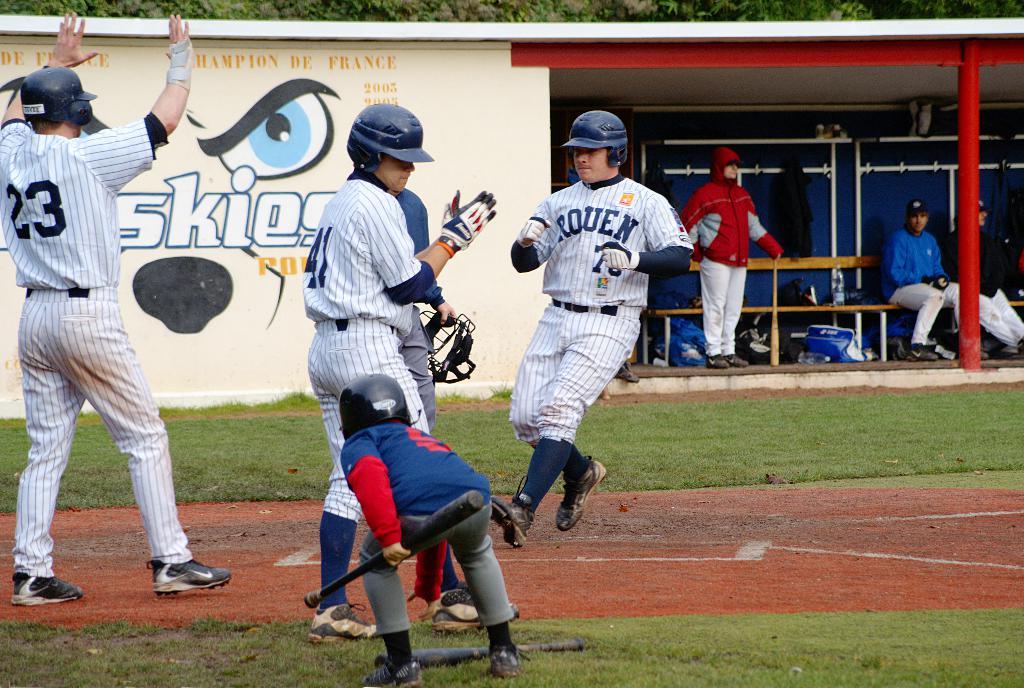What team just scored a run?
Make the answer very short. Rouen. What jersey number is the man on the left wearing?
Your response must be concise. 23. 